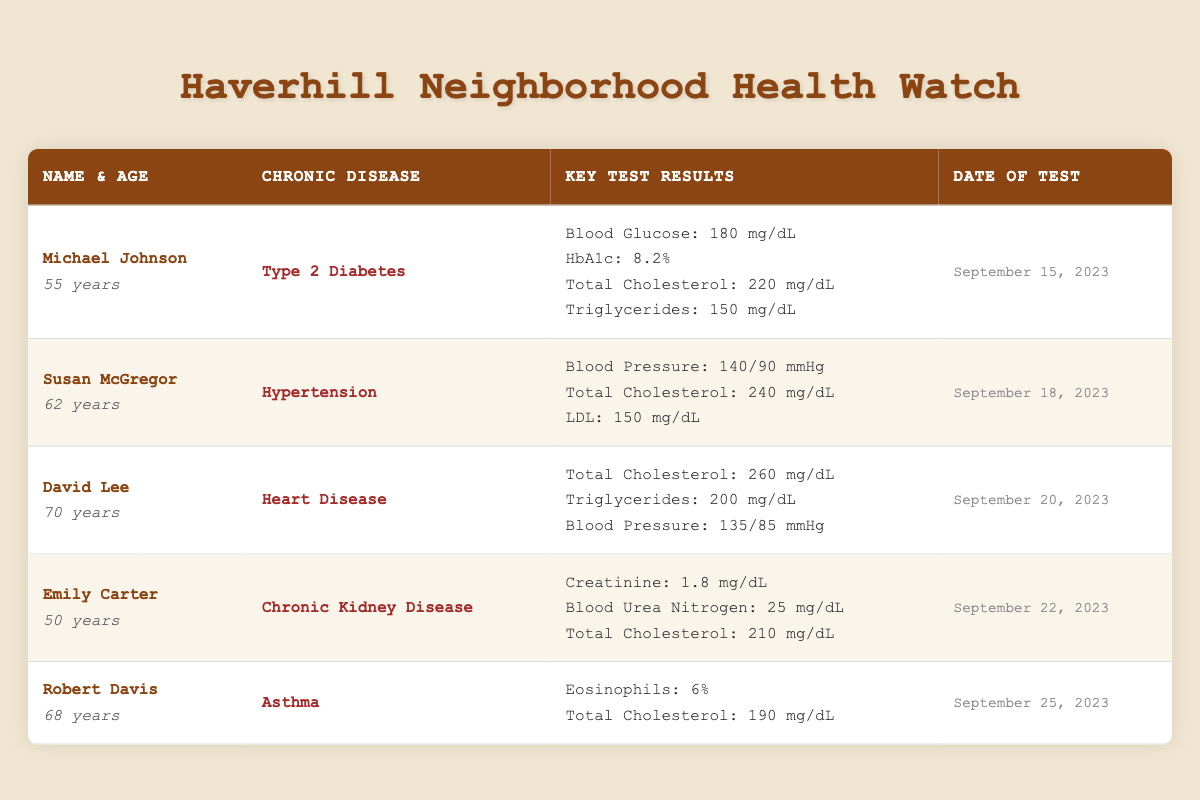What is the blood glucose level of Michael Johnson? The table indicates that Michael Johnson's blood glucose level is provided under his key test results. Looking at the row for Michael Johnson, I find a blood glucose level of 180 mg/dL.
Answer: 180 mg/dL Who has the highest total cholesterol level? To determine who has the highest total cholesterol, I will compare the total cholesterol values in each individual's key test results. Michael Johnson has 220 mg/dL, Susan McGregor has 240 mg/dL, David Lee has 260 mg/dL, Emily Carter has 210 mg/dL, and Robert Davis has 190 mg/dL. David Lee has the highest total cholesterol at 260 mg/dL.
Answer: David Lee Did Emily Carter's blood test indicate chronic kidney disease? Emily Carter's chronic disease, as stated in the table, is "Chronic Kidney Disease." This confirms that the blood test did indicate this condition.
Answer: Yes What were the average triglyceride levels among the neighbors tested? The triglyceride levels are listed for Michael Johnson (150 mg/dL), David Lee (200 mg/dL), and they are not present for Susan McGregor, Emily Carter, and Robert Davis. To find the average, I add the two present values: 150 + 200 = 350 mg/dL. There are 2 individuals with recorded triglyceride levels, so I divide by 2 to find the average: 350 / 2 = 175 mg/dL.
Answer: 175 mg/dL Is the blood pressure of Susan McGregor in a normal range? The normal range for blood pressure is generally considered to be below 120/80 mmHg. Susan's blood pressure is recorded at 140/90 mmHg, which indicates she has hypertension, a condition characterized by high blood pressure. Therefore, her blood pressure is not in a normal range.
Answer: No What is the creatinine level for Emily Carter and how does it relate to chronic kidney disease? Emily Carter's creatinine level is recorded as 1.8 mg/dL under her key test results. High creatinine levels can indicate issues with kidney function, which relates to her chronic kidney disease diagnosis. Typically, a level above 1.2 mg/dL can signal possible kidney issues. Hence, 1.8 mg/dL is elevated and relevant to her condition.
Answer: 1.8 mg/dL Which neighbor tested for hypertension and what were their key results? The neighbor with hypertension is Susan McGregor. The key results for her test include a blood pressure measurement of 140/90 mmHg, total cholesterol of 240 mg/dL, and LDL of 150 mg/dL. I can extract these specifics from her row in the table.
Answer: Susan McGregor; Blood Pressure: 140/90 mmHg, Total Cholesterol: 240 mg/dL, LDL: 150 mg/dL What were the blood pressure readings for David Lee? The table shows that David Lee's blood pressure is recorded as 135/85 mmHg. Therefore, I can refer back to his specific row in the table to directly find this information.
Answer: 135/85 mmHg 